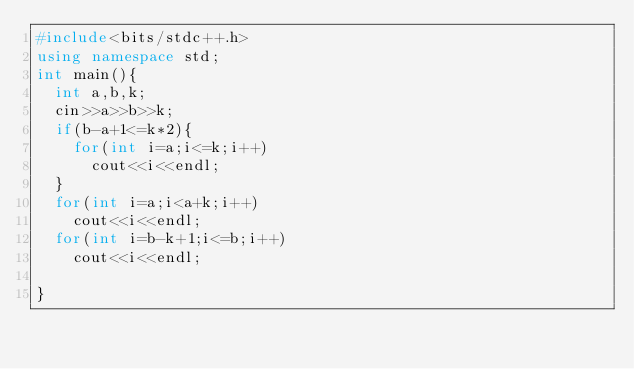Convert code to text. <code><loc_0><loc_0><loc_500><loc_500><_C++_>#include<bits/stdc++.h>
using namespace std;
int main(){
  int a,b,k;
  cin>>a>>b>>k;
  if(b-a+1<=k*2){
    for(int i=a;i<=k;i++)
      cout<<i<<endl;
  }
  for(int i=a;i<a+k;i++)
    cout<<i<<endl;
  for(int i=b-k+1;i<=b;i++)
    cout<<i<<endl;
  
}</code> 